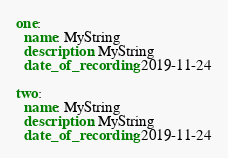Convert code to text. <code><loc_0><loc_0><loc_500><loc_500><_YAML_>
one:
  name: MyString
  description: MyString
  date_of_recording: 2019-11-24

two:
  name: MyString
  description: MyString
  date_of_recording: 2019-11-24
</code> 